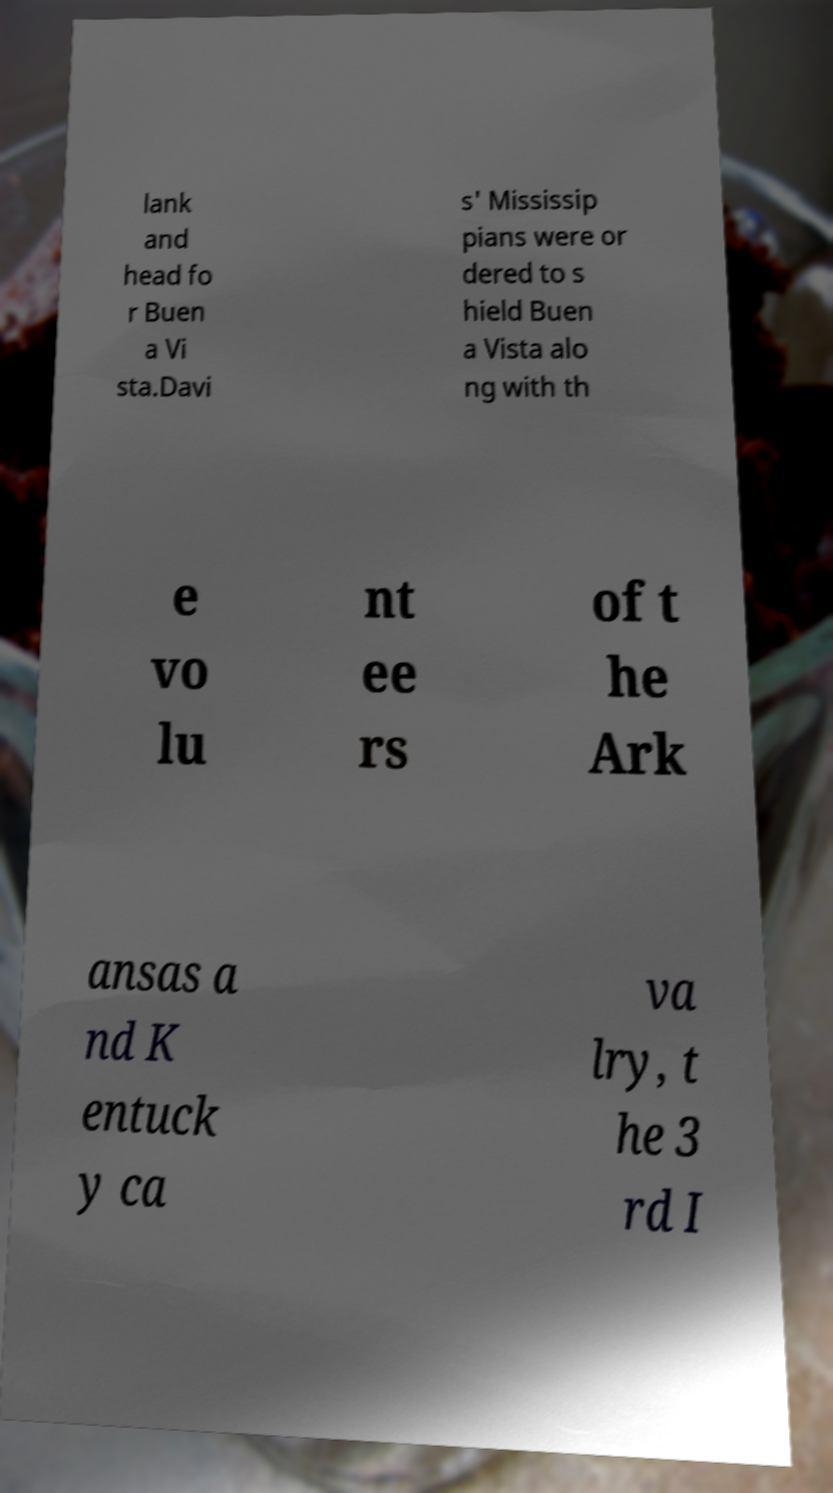What messages or text are displayed in this image? I need them in a readable, typed format. lank and head fo r Buen a Vi sta.Davi s' Mississip pians were or dered to s hield Buen a Vista alo ng with th e vo lu nt ee rs of t he Ark ansas a nd K entuck y ca va lry, t he 3 rd I 